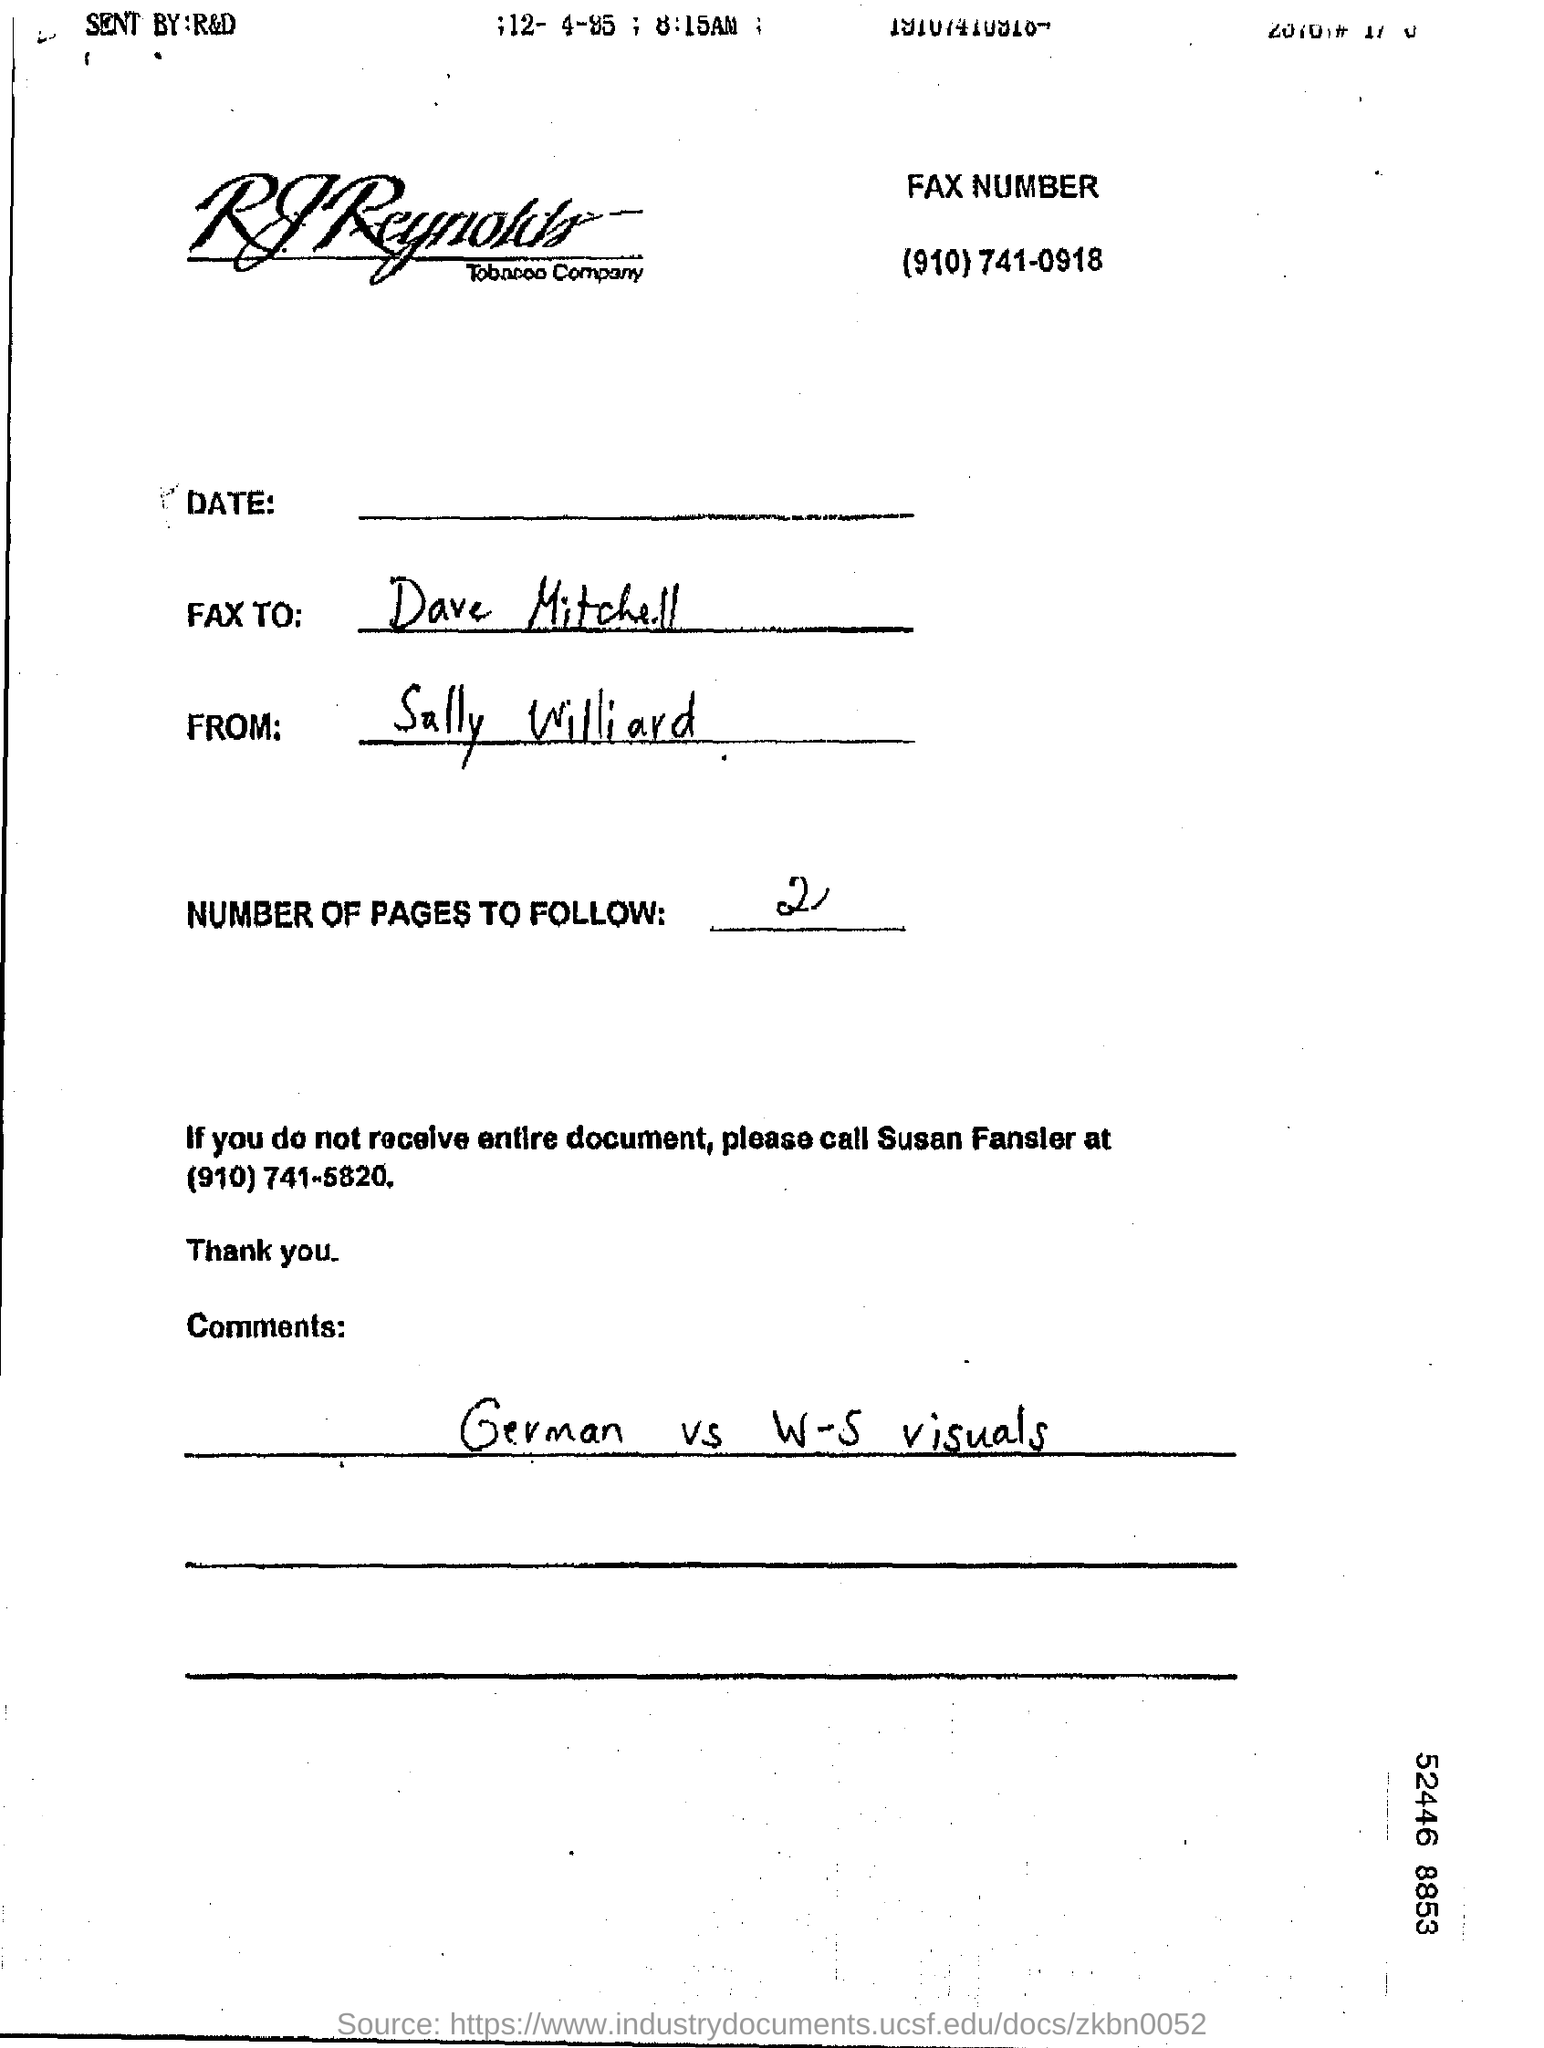What is the Fax number given?
Make the answer very short. (910)741-0918. Who is the sender of the FAX?
Your answer should be compact. Sally Williard. What are the number of pages to follow?
Give a very brief answer. 2. What are the comments mentioned ?
Keep it short and to the point. German    vs    W-S visuals. 